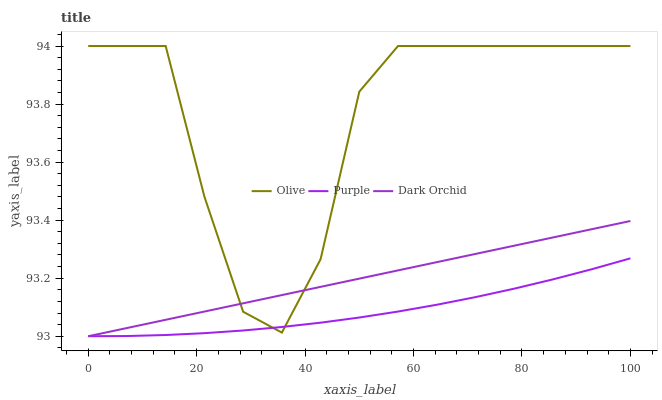Does Dark Orchid have the minimum area under the curve?
Answer yes or no. No. Does Dark Orchid have the maximum area under the curve?
Answer yes or no. No. Is Purple the smoothest?
Answer yes or no. No. Is Purple the roughest?
Answer yes or no. No. Does Purple have the lowest value?
Answer yes or no. No. Does Dark Orchid have the highest value?
Answer yes or no. No. 